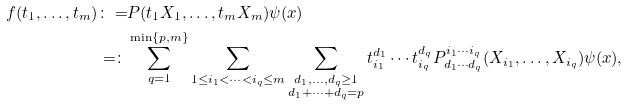Convert formula to latex. <formula><loc_0><loc_0><loc_500><loc_500>f ( t _ { 1 } , \dots , t _ { m } ) \colon = & P ( t _ { 1 } X _ { 1 } , \dots , t _ { m } X _ { m } ) \psi ( x ) \\ = \colon & \sum _ { q = 1 } ^ { \min \{ p , m \} } \sum _ { 1 \leq i _ { 1 } < \cdots < i _ { q } \leq m } \sum _ { \substack { d _ { 1 } , \dots , d _ { q } \geq 1 \\ d _ { 1 } + \cdots + d _ { q } = p } } t _ { i _ { 1 } } ^ { d _ { 1 } } \cdots t _ { i _ { q } } ^ { d _ { q } } P ^ { i _ { 1 } \cdots i _ { q } } _ { d _ { 1 } \cdots d _ { q } } ( X _ { i _ { 1 } } , \dots , X _ { i _ { q } } ) \psi ( x ) ,</formula> 